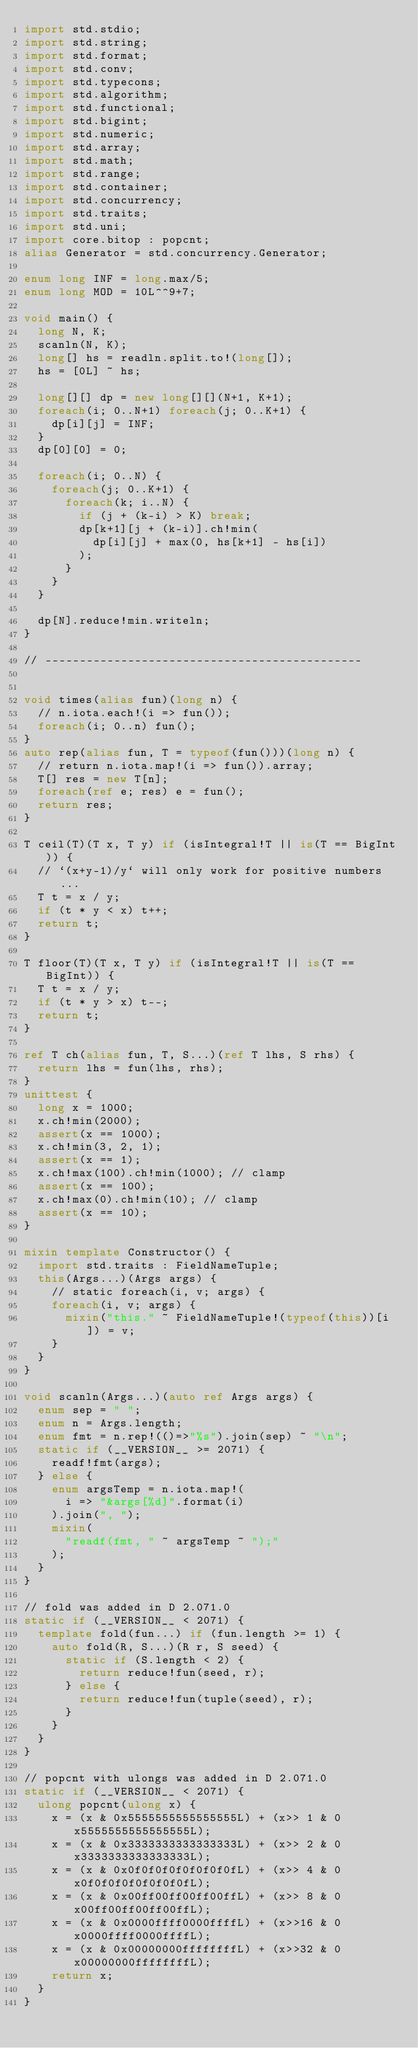Convert code to text. <code><loc_0><loc_0><loc_500><loc_500><_D_>import std.stdio;
import std.string;
import std.format;
import std.conv;
import std.typecons;
import std.algorithm;
import std.functional;
import std.bigint;
import std.numeric;
import std.array;
import std.math;
import std.range;
import std.container;
import std.concurrency;
import std.traits;
import std.uni;
import core.bitop : popcnt;
alias Generator = std.concurrency.Generator;

enum long INF = long.max/5;
enum long MOD = 10L^^9+7;

void main() {
  long N, K;
  scanln(N, K);
  long[] hs = readln.split.to!(long[]);
  hs = [0L] ~ hs;

  long[][] dp = new long[][](N+1, K+1);
  foreach(i; 0..N+1) foreach(j; 0..K+1) {
    dp[i][j] = INF;
  }
  dp[0][0] = 0;

  foreach(i; 0..N) {
    foreach(j; 0..K+1) {
      foreach(k; i..N) {
        if (j + (k-i) > K) break;
        dp[k+1][j + (k-i)].ch!min(
          dp[i][j] + max(0, hs[k+1] - hs[i])
        );
      }
    }
  }

  dp[N].reduce!min.writeln;
}

// ----------------------------------------------


void times(alias fun)(long n) {
  // n.iota.each!(i => fun());
  foreach(i; 0..n) fun();
}
auto rep(alias fun, T = typeof(fun()))(long n) {
  // return n.iota.map!(i => fun()).array;
  T[] res = new T[n];
  foreach(ref e; res) e = fun();
  return res;
}

T ceil(T)(T x, T y) if (isIntegral!T || is(T == BigInt)) {
  // `(x+y-1)/y` will only work for positive numbers ...
  T t = x / y;
  if (t * y < x) t++;
  return t;
}

T floor(T)(T x, T y) if (isIntegral!T || is(T == BigInt)) {
  T t = x / y;
  if (t * y > x) t--;
  return t;
}

ref T ch(alias fun, T, S...)(ref T lhs, S rhs) {
  return lhs = fun(lhs, rhs);
}
unittest {
  long x = 1000;
  x.ch!min(2000);
  assert(x == 1000);
  x.ch!min(3, 2, 1);
  assert(x == 1);
  x.ch!max(100).ch!min(1000); // clamp
  assert(x == 100);
  x.ch!max(0).ch!min(10); // clamp
  assert(x == 10);
}

mixin template Constructor() {
  import std.traits : FieldNameTuple;
  this(Args...)(Args args) {
    // static foreach(i, v; args) {
    foreach(i, v; args) {
      mixin("this." ~ FieldNameTuple!(typeof(this))[i]) = v;
    }
  }
}

void scanln(Args...)(auto ref Args args) {
  enum sep = " ";
  enum n = Args.length;
  enum fmt = n.rep!(()=>"%s").join(sep) ~ "\n";
  static if (__VERSION__ >= 2071) {
    readf!fmt(args);
  } else {
    enum argsTemp = n.iota.map!(
      i => "&args[%d]".format(i)
    ).join(", ");
    mixin(
      "readf(fmt, " ~ argsTemp ~ ");"
    );
  }
}

// fold was added in D 2.071.0
static if (__VERSION__ < 2071) {
  template fold(fun...) if (fun.length >= 1) {
    auto fold(R, S...)(R r, S seed) {
      static if (S.length < 2) {
        return reduce!fun(seed, r);
      } else {
        return reduce!fun(tuple(seed), r);
      }
    }
  }
}

// popcnt with ulongs was added in D 2.071.0
static if (__VERSION__ < 2071) {
  ulong popcnt(ulong x) {
    x = (x & 0x5555555555555555L) + (x>> 1 & 0x5555555555555555L);
    x = (x & 0x3333333333333333L) + (x>> 2 & 0x3333333333333333L);
    x = (x & 0x0f0f0f0f0f0f0f0fL) + (x>> 4 & 0x0f0f0f0f0f0f0f0fL);
    x = (x & 0x00ff00ff00ff00ffL) + (x>> 8 & 0x00ff00ff00ff00ffL);
    x = (x & 0x0000ffff0000ffffL) + (x>>16 & 0x0000ffff0000ffffL);
    x = (x & 0x00000000ffffffffL) + (x>>32 & 0x00000000ffffffffL);
    return x;
  }
}
</code> 